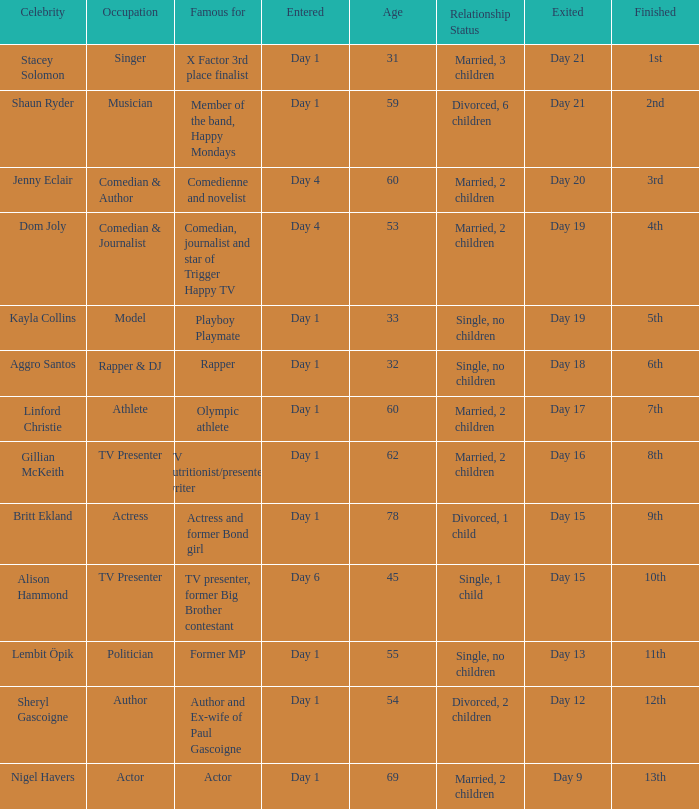What position did the celebrity finish that entered on day 1 and exited on day 19? 5th. 